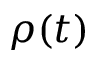Convert formula to latex. <formula><loc_0><loc_0><loc_500><loc_500>\rho ( t )</formula> 